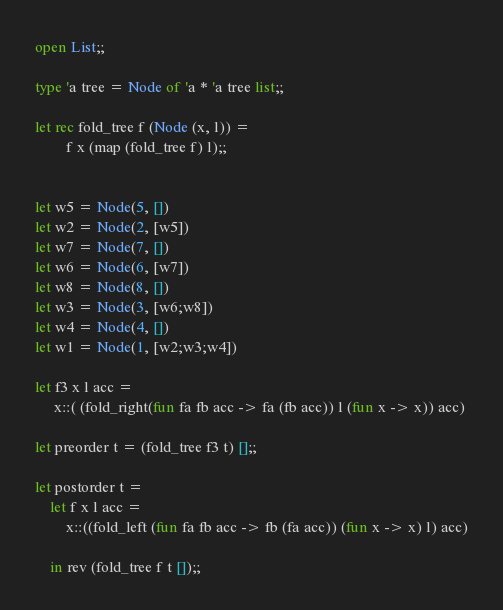Convert code to text. <code><loc_0><loc_0><loc_500><loc_500><_OCaml_>open List;;

type 'a tree = Node of 'a * 'a tree list;;

let rec fold_tree f (Node (x, l)) = 
        f x (map (fold_tree f) l);;


let w5 = Node(5, [])
let w2 = Node(2, [w5])
let w7 = Node(7, [])
let w6 = Node(6, [w7])
let w8 = Node(8, [])
let w3 = Node(3, [w6;w8])
let w4 = Node(4, [])
let w1 = Node(1, [w2;w3;w4])

let f3 x l acc =
 	 x::( (fold_right(fun fa fb acc -> fa (fb acc)) l (fun x -> x)) acc)

let preorder t = (fold_tree f3 t) [];;

let postorder t =
	let f x l acc =
		x::((fold_left (fun fa fb acc -> fb (fa acc)) (fun x -> x) l) acc)

	in rev (fold_tree f t []);;</code> 